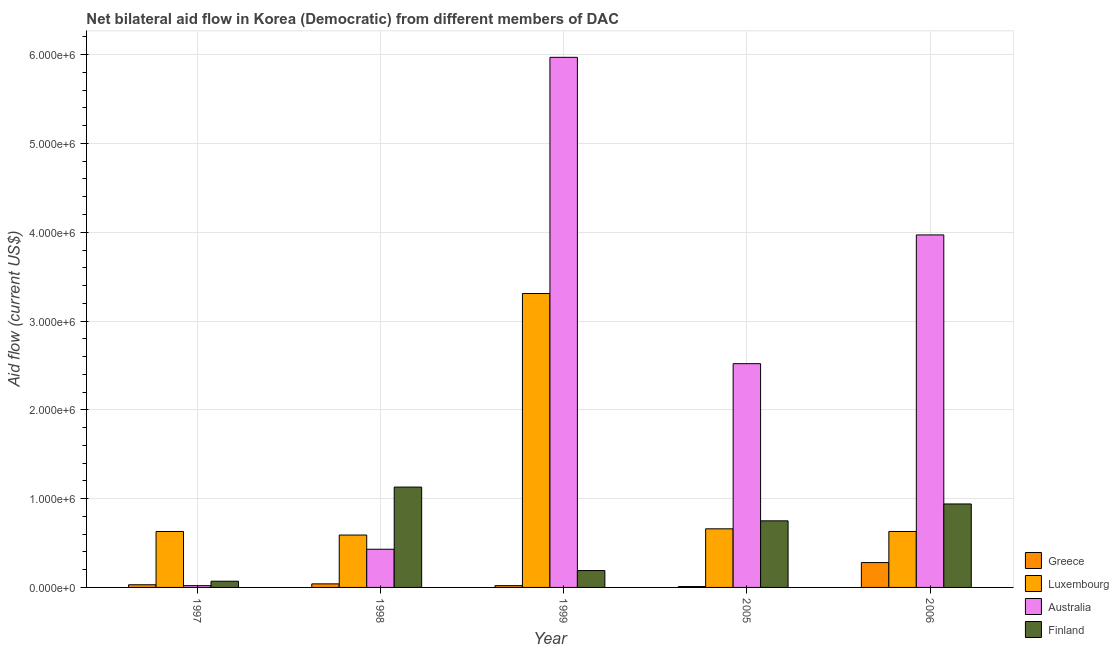Are the number of bars per tick equal to the number of legend labels?
Your answer should be compact. Yes. How many bars are there on the 2nd tick from the left?
Your response must be concise. 4. What is the label of the 3rd group of bars from the left?
Provide a short and direct response. 1999. In how many cases, is the number of bars for a given year not equal to the number of legend labels?
Offer a very short reply. 0. What is the amount of aid given by finland in 1997?
Your answer should be compact. 7.00e+04. Across all years, what is the maximum amount of aid given by finland?
Offer a very short reply. 1.13e+06. Across all years, what is the minimum amount of aid given by finland?
Make the answer very short. 7.00e+04. In which year was the amount of aid given by australia minimum?
Your answer should be very brief. 1997. What is the total amount of aid given by greece in the graph?
Ensure brevity in your answer.  3.80e+05. What is the difference between the amount of aid given by greece in 1999 and that in 2006?
Provide a short and direct response. -2.60e+05. What is the difference between the amount of aid given by finland in 2005 and the amount of aid given by greece in 1998?
Keep it short and to the point. -3.80e+05. What is the average amount of aid given by finland per year?
Make the answer very short. 6.16e+05. In the year 2006, what is the difference between the amount of aid given by finland and amount of aid given by greece?
Your response must be concise. 0. In how many years, is the amount of aid given by luxembourg greater than 3600000 US$?
Your response must be concise. 0. What is the ratio of the amount of aid given by luxembourg in 1999 to that in 2005?
Provide a succinct answer. 5.02. Is the amount of aid given by luxembourg in 1998 less than that in 2006?
Keep it short and to the point. Yes. Is the difference between the amount of aid given by finland in 1997 and 2005 greater than the difference between the amount of aid given by greece in 1997 and 2005?
Make the answer very short. No. What is the difference between the highest and the lowest amount of aid given by greece?
Your answer should be compact. 2.70e+05. In how many years, is the amount of aid given by australia greater than the average amount of aid given by australia taken over all years?
Offer a terse response. 2. What does the 3rd bar from the right in 1999 represents?
Your answer should be compact. Luxembourg. What is the difference between two consecutive major ticks on the Y-axis?
Provide a succinct answer. 1.00e+06. Are the values on the major ticks of Y-axis written in scientific E-notation?
Offer a terse response. Yes. Does the graph contain grids?
Keep it short and to the point. Yes. How are the legend labels stacked?
Offer a very short reply. Vertical. What is the title of the graph?
Give a very brief answer. Net bilateral aid flow in Korea (Democratic) from different members of DAC. Does "SF6 gas" appear as one of the legend labels in the graph?
Offer a terse response. No. What is the label or title of the X-axis?
Your response must be concise. Year. What is the Aid flow (current US$) of Greece in 1997?
Offer a terse response. 3.00e+04. What is the Aid flow (current US$) of Luxembourg in 1997?
Provide a short and direct response. 6.30e+05. What is the Aid flow (current US$) in Finland in 1997?
Offer a very short reply. 7.00e+04. What is the Aid flow (current US$) of Luxembourg in 1998?
Your answer should be compact. 5.90e+05. What is the Aid flow (current US$) of Australia in 1998?
Give a very brief answer. 4.30e+05. What is the Aid flow (current US$) of Finland in 1998?
Make the answer very short. 1.13e+06. What is the Aid flow (current US$) in Greece in 1999?
Offer a terse response. 2.00e+04. What is the Aid flow (current US$) of Luxembourg in 1999?
Make the answer very short. 3.31e+06. What is the Aid flow (current US$) in Australia in 1999?
Ensure brevity in your answer.  5.97e+06. What is the Aid flow (current US$) of Australia in 2005?
Ensure brevity in your answer.  2.52e+06. What is the Aid flow (current US$) of Finland in 2005?
Offer a terse response. 7.50e+05. What is the Aid flow (current US$) in Greece in 2006?
Keep it short and to the point. 2.80e+05. What is the Aid flow (current US$) in Luxembourg in 2006?
Your response must be concise. 6.30e+05. What is the Aid flow (current US$) of Australia in 2006?
Keep it short and to the point. 3.97e+06. What is the Aid flow (current US$) of Finland in 2006?
Your answer should be very brief. 9.40e+05. Across all years, what is the maximum Aid flow (current US$) of Greece?
Your answer should be compact. 2.80e+05. Across all years, what is the maximum Aid flow (current US$) of Luxembourg?
Provide a succinct answer. 3.31e+06. Across all years, what is the maximum Aid flow (current US$) of Australia?
Your answer should be very brief. 5.97e+06. Across all years, what is the maximum Aid flow (current US$) in Finland?
Offer a terse response. 1.13e+06. Across all years, what is the minimum Aid flow (current US$) of Greece?
Offer a very short reply. 10000. Across all years, what is the minimum Aid flow (current US$) in Luxembourg?
Keep it short and to the point. 5.90e+05. What is the total Aid flow (current US$) in Greece in the graph?
Your response must be concise. 3.80e+05. What is the total Aid flow (current US$) in Luxembourg in the graph?
Provide a short and direct response. 5.82e+06. What is the total Aid flow (current US$) in Australia in the graph?
Your response must be concise. 1.29e+07. What is the total Aid flow (current US$) in Finland in the graph?
Provide a succinct answer. 3.08e+06. What is the difference between the Aid flow (current US$) in Greece in 1997 and that in 1998?
Ensure brevity in your answer.  -10000. What is the difference between the Aid flow (current US$) of Australia in 1997 and that in 1998?
Offer a very short reply. -4.10e+05. What is the difference between the Aid flow (current US$) in Finland in 1997 and that in 1998?
Give a very brief answer. -1.06e+06. What is the difference between the Aid flow (current US$) of Luxembourg in 1997 and that in 1999?
Provide a short and direct response. -2.68e+06. What is the difference between the Aid flow (current US$) in Australia in 1997 and that in 1999?
Give a very brief answer. -5.95e+06. What is the difference between the Aid flow (current US$) of Australia in 1997 and that in 2005?
Give a very brief answer. -2.50e+06. What is the difference between the Aid flow (current US$) of Finland in 1997 and that in 2005?
Your response must be concise. -6.80e+05. What is the difference between the Aid flow (current US$) in Luxembourg in 1997 and that in 2006?
Offer a terse response. 0. What is the difference between the Aid flow (current US$) of Australia in 1997 and that in 2006?
Make the answer very short. -3.95e+06. What is the difference between the Aid flow (current US$) of Finland in 1997 and that in 2006?
Your answer should be compact. -8.70e+05. What is the difference between the Aid flow (current US$) of Greece in 1998 and that in 1999?
Provide a succinct answer. 2.00e+04. What is the difference between the Aid flow (current US$) of Luxembourg in 1998 and that in 1999?
Offer a very short reply. -2.72e+06. What is the difference between the Aid flow (current US$) of Australia in 1998 and that in 1999?
Offer a very short reply. -5.54e+06. What is the difference between the Aid flow (current US$) of Finland in 1998 and that in 1999?
Your response must be concise. 9.40e+05. What is the difference between the Aid flow (current US$) in Australia in 1998 and that in 2005?
Offer a very short reply. -2.09e+06. What is the difference between the Aid flow (current US$) of Greece in 1998 and that in 2006?
Provide a succinct answer. -2.40e+05. What is the difference between the Aid flow (current US$) in Australia in 1998 and that in 2006?
Make the answer very short. -3.54e+06. What is the difference between the Aid flow (current US$) in Greece in 1999 and that in 2005?
Provide a succinct answer. 10000. What is the difference between the Aid flow (current US$) in Luxembourg in 1999 and that in 2005?
Give a very brief answer. 2.65e+06. What is the difference between the Aid flow (current US$) in Australia in 1999 and that in 2005?
Your answer should be compact. 3.45e+06. What is the difference between the Aid flow (current US$) in Finland in 1999 and that in 2005?
Make the answer very short. -5.60e+05. What is the difference between the Aid flow (current US$) in Luxembourg in 1999 and that in 2006?
Your answer should be compact. 2.68e+06. What is the difference between the Aid flow (current US$) in Australia in 1999 and that in 2006?
Your answer should be very brief. 2.00e+06. What is the difference between the Aid flow (current US$) in Finland in 1999 and that in 2006?
Provide a short and direct response. -7.50e+05. What is the difference between the Aid flow (current US$) of Luxembourg in 2005 and that in 2006?
Give a very brief answer. 3.00e+04. What is the difference between the Aid flow (current US$) in Australia in 2005 and that in 2006?
Provide a succinct answer. -1.45e+06. What is the difference between the Aid flow (current US$) in Greece in 1997 and the Aid flow (current US$) in Luxembourg in 1998?
Offer a terse response. -5.60e+05. What is the difference between the Aid flow (current US$) of Greece in 1997 and the Aid flow (current US$) of Australia in 1998?
Your response must be concise. -4.00e+05. What is the difference between the Aid flow (current US$) in Greece in 1997 and the Aid flow (current US$) in Finland in 1998?
Provide a short and direct response. -1.10e+06. What is the difference between the Aid flow (current US$) in Luxembourg in 1997 and the Aid flow (current US$) in Finland in 1998?
Provide a succinct answer. -5.00e+05. What is the difference between the Aid flow (current US$) of Australia in 1997 and the Aid flow (current US$) of Finland in 1998?
Provide a succinct answer. -1.11e+06. What is the difference between the Aid flow (current US$) in Greece in 1997 and the Aid flow (current US$) in Luxembourg in 1999?
Make the answer very short. -3.28e+06. What is the difference between the Aid flow (current US$) in Greece in 1997 and the Aid flow (current US$) in Australia in 1999?
Offer a very short reply. -5.94e+06. What is the difference between the Aid flow (current US$) of Luxembourg in 1997 and the Aid flow (current US$) of Australia in 1999?
Your answer should be compact. -5.34e+06. What is the difference between the Aid flow (current US$) in Australia in 1997 and the Aid flow (current US$) in Finland in 1999?
Your answer should be compact. -1.70e+05. What is the difference between the Aid flow (current US$) in Greece in 1997 and the Aid flow (current US$) in Luxembourg in 2005?
Your answer should be very brief. -6.30e+05. What is the difference between the Aid flow (current US$) of Greece in 1997 and the Aid flow (current US$) of Australia in 2005?
Offer a very short reply. -2.49e+06. What is the difference between the Aid flow (current US$) in Greece in 1997 and the Aid flow (current US$) in Finland in 2005?
Ensure brevity in your answer.  -7.20e+05. What is the difference between the Aid flow (current US$) in Luxembourg in 1997 and the Aid flow (current US$) in Australia in 2005?
Make the answer very short. -1.89e+06. What is the difference between the Aid flow (current US$) in Luxembourg in 1997 and the Aid flow (current US$) in Finland in 2005?
Offer a terse response. -1.20e+05. What is the difference between the Aid flow (current US$) of Australia in 1997 and the Aid flow (current US$) of Finland in 2005?
Give a very brief answer. -7.30e+05. What is the difference between the Aid flow (current US$) in Greece in 1997 and the Aid flow (current US$) in Luxembourg in 2006?
Offer a terse response. -6.00e+05. What is the difference between the Aid flow (current US$) in Greece in 1997 and the Aid flow (current US$) in Australia in 2006?
Offer a terse response. -3.94e+06. What is the difference between the Aid flow (current US$) in Greece in 1997 and the Aid flow (current US$) in Finland in 2006?
Keep it short and to the point. -9.10e+05. What is the difference between the Aid flow (current US$) in Luxembourg in 1997 and the Aid flow (current US$) in Australia in 2006?
Give a very brief answer. -3.34e+06. What is the difference between the Aid flow (current US$) in Luxembourg in 1997 and the Aid flow (current US$) in Finland in 2006?
Ensure brevity in your answer.  -3.10e+05. What is the difference between the Aid flow (current US$) in Australia in 1997 and the Aid flow (current US$) in Finland in 2006?
Offer a very short reply. -9.20e+05. What is the difference between the Aid flow (current US$) in Greece in 1998 and the Aid flow (current US$) in Luxembourg in 1999?
Your response must be concise. -3.27e+06. What is the difference between the Aid flow (current US$) in Greece in 1998 and the Aid flow (current US$) in Australia in 1999?
Make the answer very short. -5.93e+06. What is the difference between the Aid flow (current US$) in Greece in 1998 and the Aid flow (current US$) in Finland in 1999?
Your answer should be very brief. -1.50e+05. What is the difference between the Aid flow (current US$) in Luxembourg in 1998 and the Aid flow (current US$) in Australia in 1999?
Give a very brief answer. -5.38e+06. What is the difference between the Aid flow (current US$) in Greece in 1998 and the Aid flow (current US$) in Luxembourg in 2005?
Keep it short and to the point. -6.20e+05. What is the difference between the Aid flow (current US$) in Greece in 1998 and the Aid flow (current US$) in Australia in 2005?
Your response must be concise. -2.48e+06. What is the difference between the Aid flow (current US$) of Greece in 1998 and the Aid flow (current US$) of Finland in 2005?
Make the answer very short. -7.10e+05. What is the difference between the Aid flow (current US$) in Luxembourg in 1998 and the Aid flow (current US$) in Australia in 2005?
Your response must be concise. -1.93e+06. What is the difference between the Aid flow (current US$) in Luxembourg in 1998 and the Aid flow (current US$) in Finland in 2005?
Keep it short and to the point. -1.60e+05. What is the difference between the Aid flow (current US$) of Australia in 1998 and the Aid flow (current US$) of Finland in 2005?
Keep it short and to the point. -3.20e+05. What is the difference between the Aid flow (current US$) in Greece in 1998 and the Aid flow (current US$) in Luxembourg in 2006?
Your response must be concise. -5.90e+05. What is the difference between the Aid flow (current US$) of Greece in 1998 and the Aid flow (current US$) of Australia in 2006?
Offer a very short reply. -3.93e+06. What is the difference between the Aid flow (current US$) in Greece in 1998 and the Aid flow (current US$) in Finland in 2006?
Your response must be concise. -9.00e+05. What is the difference between the Aid flow (current US$) in Luxembourg in 1998 and the Aid flow (current US$) in Australia in 2006?
Your response must be concise. -3.38e+06. What is the difference between the Aid flow (current US$) of Luxembourg in 1998 and the Aid flow (current US$) of Finland in 2006?
Keep it short and to the point. -3.50e+05. What is the difference between the Aid flow (current US$) of Australia in 1998 and the Aid flow (current US$) of Finland in 2006?
Offer a very short reply. -5.10e+05. What is the difference between the Aid flow (current US$) of Greece in 1999 and the Aid flow (current US$) of Luxembourg in 2005?
Make the answer very short. -6.40e+05. What is the difference between the Aid flow (current US$) in Greece in 1999 and the Aid flow (current US$) in Australia in 2005?
Provide a short and direct response. -2.50e+06. What is the difference between the Aid flow (current US$) in Greece in 1999 and the Aid flow (current US$) in Finland in 2005?
Give a very brief answer. -7.30e+05. What is the difference between the Aid flow (current US$) of Luxembourg in 1999 and the Aid flow (current US$) of Australia in 2005?
Provide a short and direct response. 7.90e+05. What is the difference between the Aid flow (current US$) in Luxembourg in 1999 and the Aid flow (current US$) in Finland in 2005?
Provide a short and direct response. 2.56e+06. What is the difference between the Aid flow (current US$) of Australia in 1999 and the Aid flow (current US$) of Finland in 2005?
Your answer should be very brief. 5.22e+06. What is the difference between the Aid flow (current US$) of Greece in 1999 and the Aid flow (current US$) of Luxembourg in 2006?
Keep it short and to the point. -6.10e+05. What is the difference between the Aid flow (current US$) in Greece in 1999 and the Aid flow (current US$) in Australia in 2006?
Your response must be concise. -3.95e+06. What is the difference between the Aid flow (current US$) in Greece in 1999 and the Aid flow (current US$) in Finland in 2006?
Ensure brevity in your answer.  -9.20e+05. What is the difference between the Aid flow (current US$) of Luxembourg in 1999 and the Aid flow (current US$) of Australia in 2006?
Give a very brief answer. -6.60e+05. What is the difference between the Aid flow (current US$) of Luxembourg in 1999 and the Aid flow (current US$) of Finland in 2006?
Your answer should be compact. 2.37e+06. What is the difference between the Aid flow (current US$) in Australia in 1999 and the Aid flow (current US$) in Finland in 2006?
Give a very brief answer. 5.03e+06. What is the difference between the Aid flow (current US$) in Greece in 2005 and the Aid flow (current US$) in Luxembourg in 2006?
Ensure brevity in your answer.  -6.20e+05. What is the difference between the Aid flow (current US$) of Greece in 2005 and the Aid flow (current US$) of Australia in 2006?
Ensure brevity in your answer.  -3.96e+06. What is the difference between the Aid flow (current US$) of Greece in 2005 and the Aid flow (current US$) of Finland in 2006?
Offer a terse response. -9.30e+05. What is the difference between the Aid flow (current US$) of Luxembourg in 2005 and the Aid flow (current US$) of Australia in 2006?
Provide a short and direct response. -3.31e+06. What is the difference between the Aid flow (current US$) in Luxembourg in 2005 and the Aid flow (current US$) in Finland in 2006?
Provide a short and direct response. -2.80e+05. What is the difference between the Aid flow (current US$) in Australia in 2005 and the Aid flow (current US$) in Finland in 2006?
Provide a succinct answer. 1.58e+06. What is the average Aid flow (current US$) of Greece per year?
Your answer should be very brief. 7.60e+04. What is the average Aid flow (current US$) in Luxembourg per year?
Ensure brevity in your answer.  1.16e+06. What is the average Aid flow (current US$) in Australia per year?
Provide a succinct answer. 2.58e+06. What is the average Aid flow (current US$) of Finland per year?
Provide a short and direct response. 6.16e+05. In the year 1997, what is the difference between the Aid flow (current US$) of Greece and Aid flow (current US$) of Luxembourg?
Provide a succinct answer. -6.00e+05. In the year 1997, what is the difference between the Aid flow (current US$) of Luxembourg and Aid flow (current US$) of Finland?
Ensure brevity in your answer.  5.60e+05. In the year 1998, what is the difference between the Aid flow (current US$) in Greece and Aid flow (current US$) in Luxembourg?
Your response must be concise. -5.50e+05. In the year 1998, what is the difference between the Aid flow (current US$) in Greece and Aid flow (current US$) in Australia?
Your answer should be compact. -3.90e+05. In the year 1998, what is the difference between the Aid flow (current US$) in Greece and Aid flow (current US$) in Finland?
Ensure brevity in your answer.  -1.09e+06. In the year 1998, what is the difference between the Aid flow (current US$) of Luxembourg and Aid flow (current US$) of Australia?
Offer a terse response. 1.60e+05. In the year 1998, what is the difference between the Aid flow (current US$) in Luxembourg and Aid flow (current US$) in Finland?
Your answer should be very brief. -5.40e+05. In the year 1998, what is the difference between the Aid flow (current US$) of Australia and Aid flow (current US$) of Finland?
Your response must be concise. -7.00e+05. In the year 1999, what is the difference between the Aid flow (current US$) in Greece and Aid flow (current US$) in Luxembourg?
Offer a terse response. -3.29e+06. In the year 1999, what is the difference between the Aid flow (current US$) of Greece and Aid flow (current US$) of Australia?
Offer a terse response. -5.95e+06. In the year 1999, what is the difference between the Aid flow (current US$) of Greece and Aid flow (current US$) of Finland?
Your answer should be compact. -1.70e+05. In the year 1999, what is the difference between the Aid flow (current US$) in Luxembourg and Aid flow (current US$) in Australia?
Your answer should be very brief. -2.66e+06. In the year 1999, what is the difference between the Aid flow (current US$) in Luxembourg and Aid flow (current US$) in Finland?
Offer a very short reply. 3.12e+06. In the year 1999, what is the difference between the Aid flow (current US$) of Australia and Aid flow (current US$) of Finland?
Your answer should be compact. 5.78e+06. In the year 2005, what is the difference between the Aid flow (current US$) in Greece and Aid flow (current US$) in Luxembourg?
Ensure brevity in your answer.  -6.50e+05. In the year 2005, what is the difference between the Aid flow (current US$) of Greece and Aid flow (current US$) of Australia?
Your answer should be very brief. -2.51e+06. In the year 2005, what is the difference between the Aid flow (current US$) of Greece and Aid flow (current US$) of Finland?
Make the answer very short. -7.40e+05. In the year 2005, what is the difference between the Aid flow (current US$) in Luxembourg and Aid flow (current US$) in Australia?
Your response must be concise. -1.86e+06. In the year 2005, what is the difference between the Aid flow (current US$) of Australia and Aid flow (current US$) of Finland?
Offer a terse response. 1.77e+06. In the year 2006, what is the difference between the Aid flow (current US$) of Greece and Aid flow (current US$) of Luxembourg?
Ensure brevity in your answer.  -3.50e+05. In the year 2006, what is the difference between the Aid flow (current US$) of Greece and Aid flow (current US$) of Australia?
Provide a short and direct response. -3.69e+06. In the year 2006, what is the difference between the Aid flow (current US$) of Greece and Aid flow (current US$) of Finland?
Your answer should be very brief. -6.60e+05. In the year 2006, what is the difference between the Aid flow (current US$) in Luxembourg and Aid flow (current US$) in Australia?
Offer a terse response. -3.34e+06. In the year 2006, what is the difference between the Aid flow (current US$) in Luxembourg and Aid flow (current US$) in Finland?
Ensure brevity in your answer.  -3.10e+05. In the year 2006, what is the difference between the Aid flow (current US$) in Australia and Aid flow (current US$) in Finland?
Give a very brief answer. 3.03e+06. What is the ratio of the Aid flow (current US$) in Greece in 1997 to that in 1998?
Keep it short and to the point. 0.75. What is the ratio of the Aid flow (current US$) of Luxembourg in 1997 to that in 1998?
Your answer should be very brief. 1.07. What is the ratio of the Aid flow (current US$) in Australia in 1997 to that in 1998?
Offer a very short reply. 0.05. What is the ratio of the Aid flow (current US$) in Finland in 1997 to that in 1998?
Provide a succinct answer. 0.06. What is the ratio of the Aid flow (current US$) in Greece in 1997 to that in 1999?
Make the answer very short. 1.5. What is the ratio of the Aid flow (current US$) of Luxembourg in 1997 to that in 1999?
Offer a terse response. 0.19. What is the ratio of the Aid flow (current US$) in Australia in 1997 to that in 1999?
Offer a terse response. 0. What is the ratio of the Aid flow (current US$) in Finland in 1997 to that in 1999?
Keep it short and to the point. 0.37. What is the ratio of the Aid flow (current US$) of Greece in 1997 to that in 2005?
Make the answer very short. 3. What is the ratio of the Aid flow (current US$) of Luxembourg in 1997 to that in 2005?
Your answer should be compact. 0.95. What is the ratio of the Aid flow (current US$) of Australia in 1997 to that in 2005?
Your response must be concise. 0.01. What is the ratio of the Aid flow (current US$) of Finland in 1997 to that in 2005?
Your answer should be very brief. 0.09. What is the ratio of the Aid flow (current US$) in Greece in 1997 to that in 2006?
Your response must be concise. 0.11. What is the ratio of the Aid flow (current US$) of Australia in 1997 to that in 2006?
Provide a short and direct response. 0.01. What is the ratio of the Aid flow (current US$) of Finland in 1997 to that in 2006?
Provide a short and direct response. 0.07. What is the ratio of the Aid flow (current US$) in Greece in 1998 to that in 1999?
Your answer should be compact. 2. What is the ratio of the Aid flow (current US$) of Luxembourg in 1998 to that in 1999?
Ensure brevity in your answer.  0.18. What is the ratio of the Aid flow (current US$) in Australia in 1998 to that in 1999?
Offer a very short reply. 0.07. What is the ratio of the Aid flow (current US$) of Finland in 1998 to that in 1999?
Give a very brief answer. 5.95. What is the ratio of the Aid flow (current US$) in Greece in 1998 to that in 2005?
Your answer should be very brief. 4. What is the ratio of the Aid flow (current US$) in Luxembourg in 1998 to that in 2005?
Your answer should be compact. 0.89. What is the ratio of the Aid flow (current US$) of Australia in 1998 to that in 2005?
Your response must be concise. 0.17. What is the ratio of the Aid flow (current US$) in Finland in 1998 to that in 2005?
Offer a terse response. 1.51. What is the ratio of the Aid flow (current US$) in Greece in 1998 to that in 2006?
Your answer should be compact. 0.14. What is the ratio of the Aid flow (current US$) in Luxembourg in 1998 to that in 2006?
Offer a very short reply. 0.94. What is the ratio of the Aid flow (current US$) in Australia in 1998 to that in 2006?
Your answer should be compact. 0.11. What is the ratio of the Aid flow (current US$) of Finland in 1998 to that in 2006?
Ensure brevity in your answer.  1.2. What is the ratio of the Aid flow (current US$) of Greece in 1999 to that in 2005?
Ensure brevity in your answer.  2. What is the ratio of the Aid flow (current US$) of Luxembourg in 1999 to that in 2005?
Your answer should be compact. 5.02. What is the ratio of the Aid flow (current US$) in Australia in 1999 to that in 2005?
Keep it short and to the point. 2.37. What is the ratio of the Aid flow (current US$) of Finland in 1999 to that in 2005?
Give a very brief answer. 0.25. What is the ratio of the Aid flow (current US$) in Greece in 1999 to that in 2006?
Offer a terse response. 0.07. What is the ratio of the Aid flow (current US$) of Luxembourg in 1999 to that in 2006?
Your answer should be compact. 5.25. What is the ratio of the Aid flow (current US$) of Australia in 1999 to that in 2006?
Make the answer very short. 1.5. What is the ratio of the Aid flow (current US$) in Finland in 1999 to that in 2006?
Keep it short and to the point. 0.2. What is the ratio of the Aid flow (current US$) in Greece in 2005 to that in 2006?
Your response must be concise. 0.04. What is the ratio of the Aid flow (current US$) of Luxembourg in 2005 to that in 2006?
Provide a short and direct response. 1.05. What is the ratio of the Aid flow (current US$) in Australia in 2005 to that in 2006?
Ensure brevity in your answer.  0.63. What is the ratio of the Aid flow (current US$) in Finland in 2005 to that in 2006?
Your answer should be compact. 0.8. What is the difference between the highest and the second highest Aid flow (current US$) in Luxembourg?
Provide a succinct answer. 2.65e+06. What is the difference between the highest and the second highest Aid flow (current US$) in Australia?
Provide a succinct answer. 2.00e+06. What is the difference between the highest and the lowest Aid flow (current US$) of Greece?
Your answer should be compact. 2.70e+05. What is the difference between the highest and the lowest Aid flow (current US$) of Luxembourg?
Ensure brevity in your answer.  2.72e+06. What is the difference between the highest and the lowest Aid flow (current US$) of Australia?
Your answer should be very brief. 5.95e+06. What is the difference between the highest and the lowest Aid flow (current US$) of Finland?
Keep it short and to the point. 1.06e+06. 